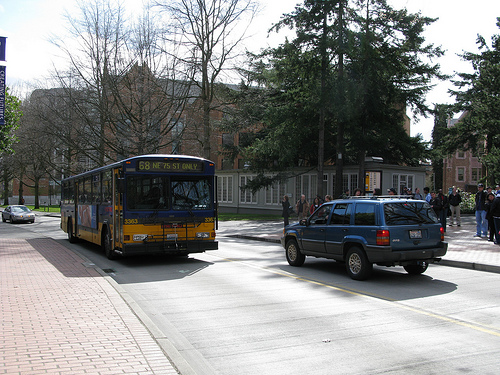What's the weather like in this image? The weather appears to be clear and sunny, as evidenced by the shadows on the ground and the lack of any precipitation or overcast skies. 